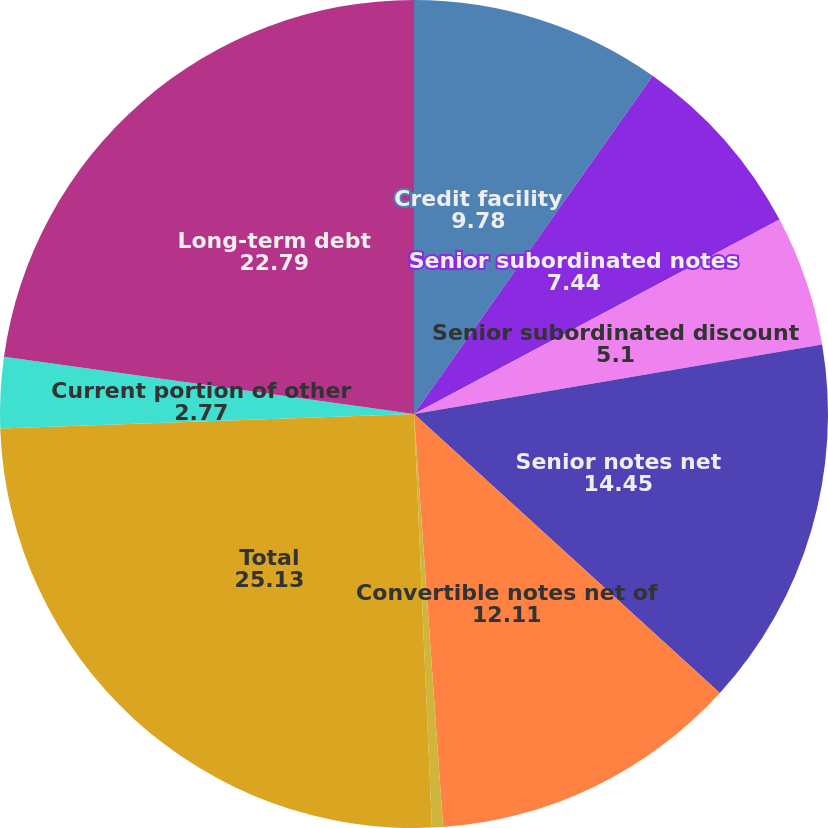Convert chart to OTSL. <chart><loc_0><loc_0><loc_500><loc_500><pie_chart><fcel>Credit facility<fcel>Senior subordinated notes<fcel>Senior subordinated discount<fcel>Senior notes net<fcel>Convertible notes net of<fcel>Notes payable and capital<fcel>Total<fcel>Current portion of other<fcel>Long-term debt<nl><fcel>9.78%<fcel>7.44%<fcel>5.1%<fcel>14.45%<fcel>12.11%<fcel>0.43%<fcel>25.13%<fcel>2.77%<fcel>22.79%<nl></chart> 